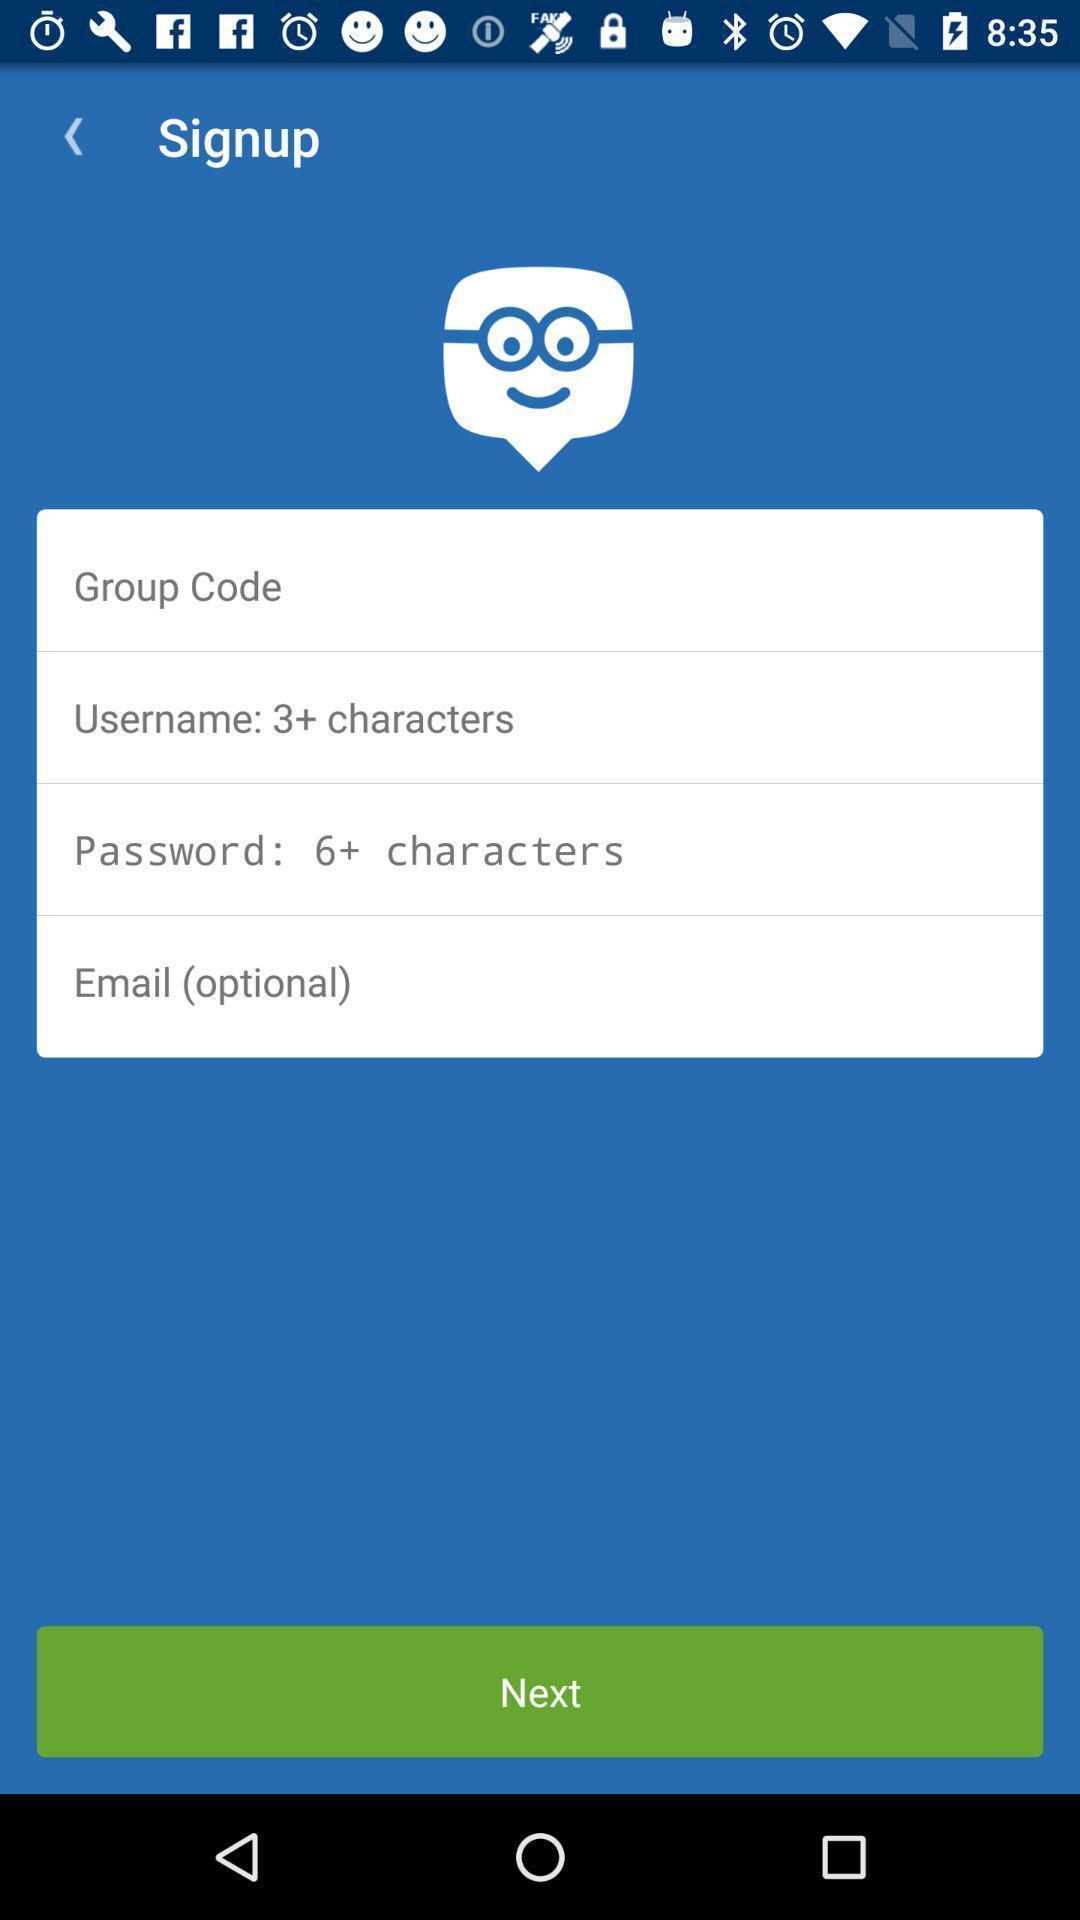Provide a detailed account of this screenshot. Welcome page for an app. 